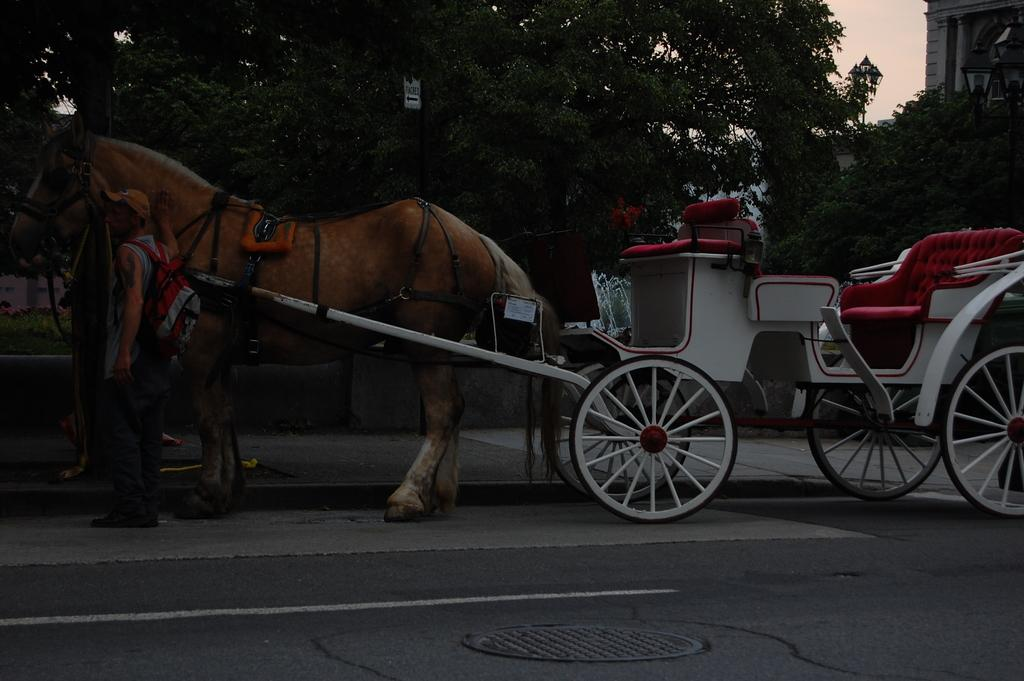What is the main subject in the center of the image? There is a horse cart in the center of the image. Who is present near the horse cart? There is a man standing near the horse cart. What can be seen on the man's clothing? The man is wearing a red and grey color bag. What can be seen in the background of the image? There are trees and a building in the background of the image. What type of haircut does the horse have in the image? The image does not show the horse's haircut, as it only features a horse cart and a man standing near it. 